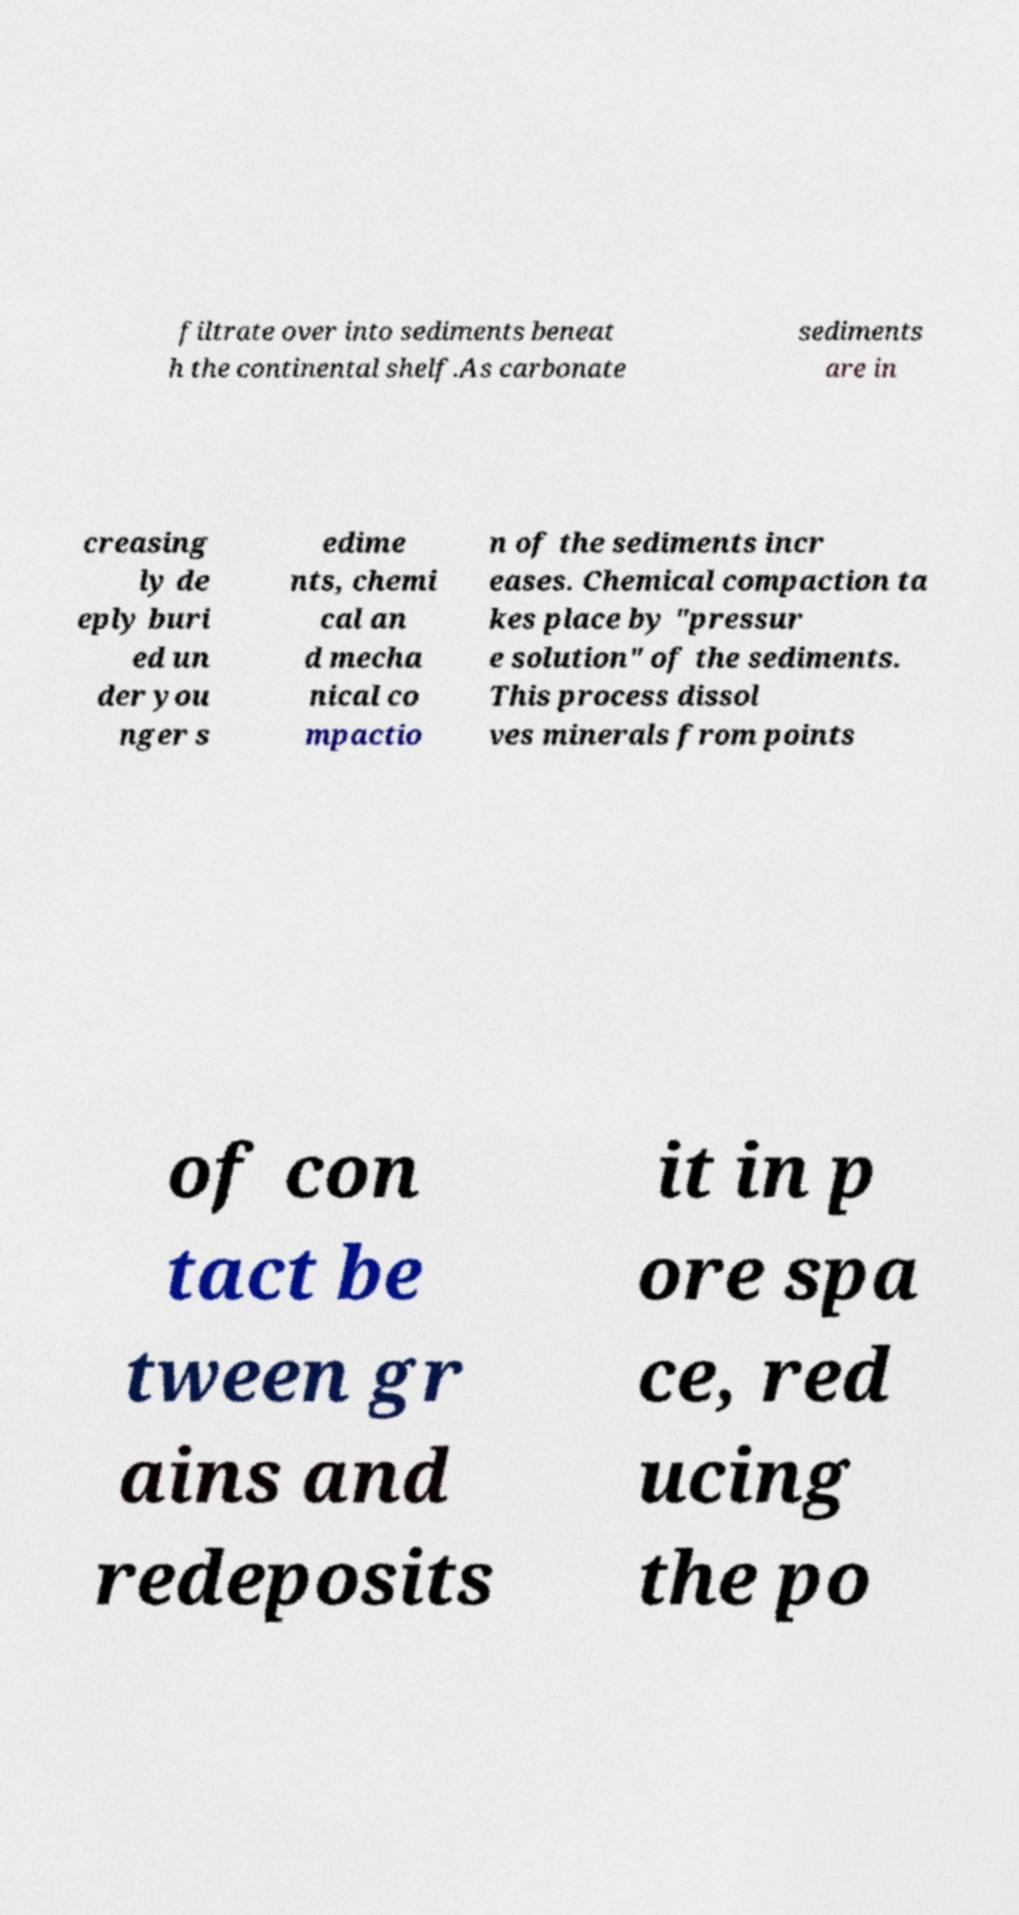Please identify and transcribe the text found in this image. filtrate over into sediments beneat h the continental shelf.As carbonate sediments are in creasing ly de eply buri ed un der you nger s edime nts, chemi cal an d mecha nical co mpactio n of the sediments incr eases. Chemical compaction ta kes place by "pressur e solution" of the sediments. This process dissol ves minerals from points of con tact be tween gr ains and redeposits it in p ore spa ce, red ucing the po 